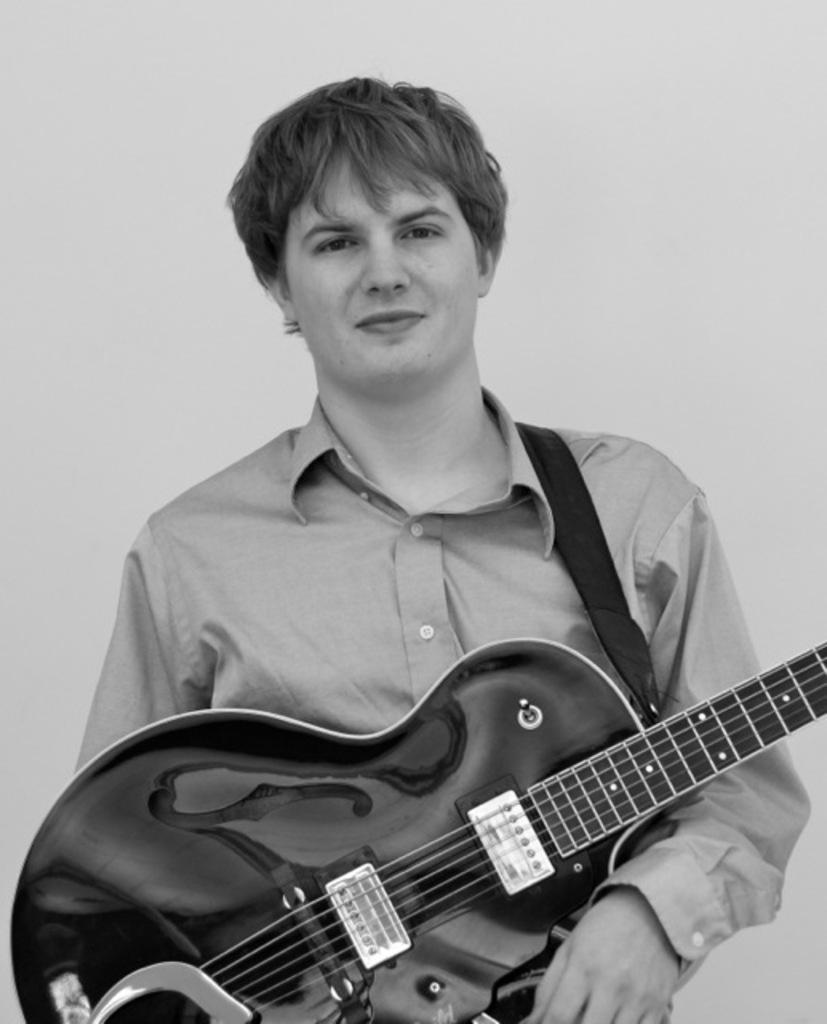Can you describe this image briefly? In the image we can see there is a man who is holding a guitar in his hand and the image is in black and white colour. 